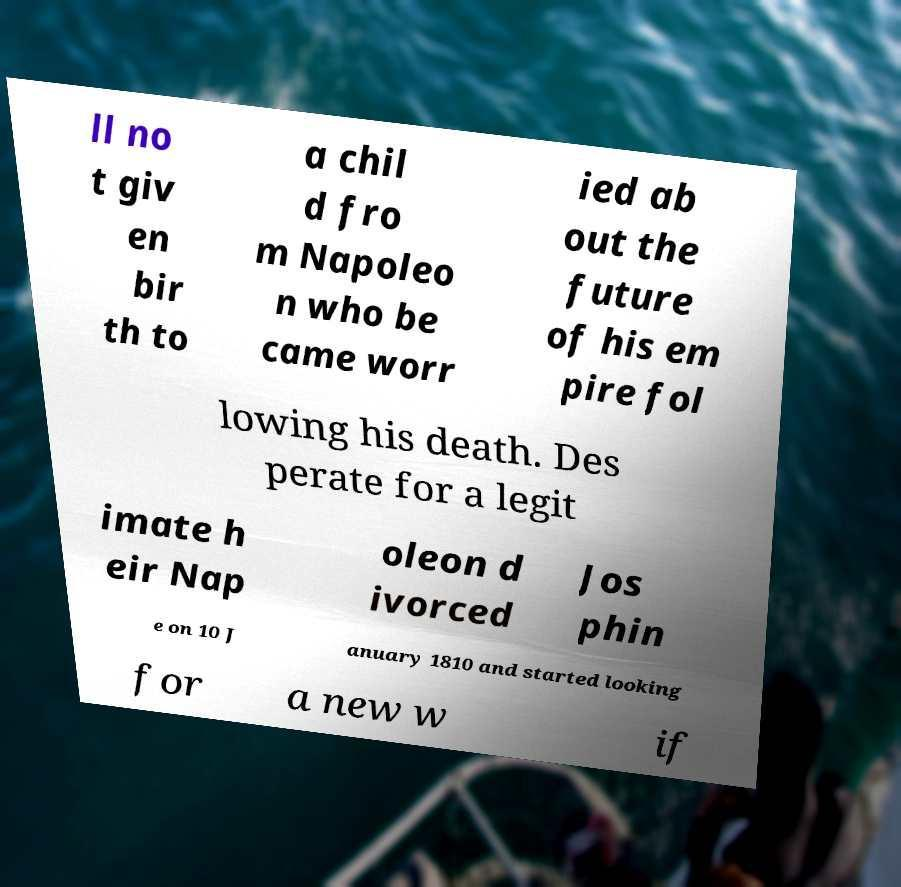There's text embedded in this image that I need extracted. Can you transcribe it verbatim? ll no t giv en bir th to a chil d fro m Napoleo n who be came worr ied ab out the future of his em pire fol lowing his death. Des perate for a legit imate h eir Nap oleon d ivorced Jos phin e on 10 J anuary 1810 and started looking for a new w if 